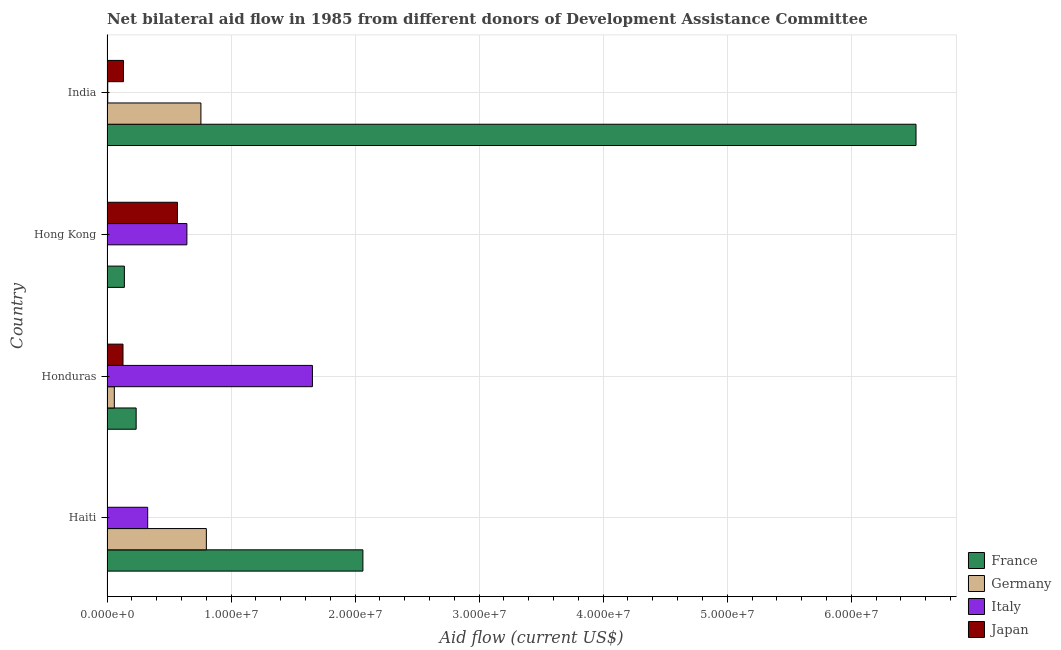How many groups of bars are there?
Keep it short and to the point. 4. Are the number of bars per tick equal to the number of legend labels?
Make the answer very short. No. What is the label of the 1st group of bars from the top?
Ensure brevity in your answer.  India. In how many cases, is the number of bars for a given country not equal to the number of legend labels?
Your response must be concise. 1. What is the amount of aid given by japan in Haiti?
Your answer should be compact. 3.00e+04. Across all countries, what is the maximum amount of aid given by germany?
Provide a succinct answer. 8.01e+06. Across all countries, what is the minimum amount of aid given by germany?
Your answer should be compact. 0. In which country was the amount of aid given by italy maximum?
Your answer should be compact. Honduras. What is the total amount of aid given by germany in the graph?
Your response must be concise. 1.62e+07. What is the difference between the amount of aid given by italy in Haiti and that in India?
Offer a terse response. 3.22e+06. What is the difference between the amount of aid given by japan in Hong Kong and the amount of aid given by italy in Haiti?
Provide a short and direct response. 2.40e+06. What is the average amount of aid given by france per country?
Your response must be concise. 2.24e+07. What is the difference between the amount of aid given by japan and amount of aid given by germany in Haiti?
Offer a very short reply. -7.98e+06. What is the ratio of the amount of aid given by france in Haiti to that in Honduras?
Offer a very short reply. 8.78. Is the difference between the amount of aid given by japan in Haiti and India greater than the difference between the amount of aid given by france in Haiti and India?
Give a very brief answer. Yes. What is the difference between the highest and the second highest amount of aid given by italy?
Your response must be concise. 1.01e+07. What is the difference between the highest and the lowest amount of aid given by italy?
Offer a terse response. 1.65e+07. In how many countries, is the amount of aid given by france greater than the average amount of aid given by france taken over all countries?
Give a very brief answer. 1. Does the graph contain grids?
Provide a short and direct response. Yes. Where does the legend appear in the graph?
Make the answer very short. Bottom right. How are the legend labels stacked?
Give a very brief answer. Vertical. What is the title of the graph?
Your response must be concise. Net bilateral aid flow in 1985 from different donors of Development Assistance Committee. What is the label or title of the X-axis?
Your response must be concise. Aid flow (current US$). What is the label or title of the Y-axis?
Offer a terse response. Country. What is the Aid flow (current US$) in France in Haiti?
Your response must be concise. 2.06e+07. What is the Aid flow (current US$) of Germany in Haiti?
Offer a terse response. 8.01e+06. What is the Aid flow (current US$) in Italy in Haiti?
Give a very brief answer. 3.28e+06. What is the Aid flow (current US$) of Japan in Haiti?
Provide a short and direct response. 3.00e+04. What is the Aid flow (current US$) of France in Honduras?
Provide a succinct answer. 2.35e+06. What is the Aid flow (current US$) of Germany in Honduras?
Your response must be concise. 5.90e+05. What is the Aid flow (current US$) of Italy in Honduras?
Ensure brevity in your answer.  1.66e+07. What is the Aid flow (current US$) in Japan in Honduras?
Your response must be concise. 1.29e+06. What is the Aid flow (current US$) in France in Hong Kong?
Provide a short and direct response. 1.40e+06. What is the Aid flow (current US$) of Italy in Hong Kong?
Make the answer very short. 6.44e+06. What is the Aid flow (current US$) in Japan in Hong Kong?
Make the answer very short. 5.68e+06. What is the Aid flow (current US$) in France in India?
Provide a short and direct response. 6.52e+07. What is the Aid flow (current US$) of Germany in India?
Ensure brevity in your answer.  7.57e+06. What is the Aid flow (current US$) in Italy in India?
Your answer should be very brief. 6.00e+04. What is the Aid flow (current US$) in Japan in India?
Your answer should be compact. 1.33e+06. Across all countries, what is the maximum Aid flow (current US$) in France?
Your answer should be compact. 6.52e+07. Across all countries, what is the maximum Aid flow (current US$) of Germany?
Ensure brevity in your answer.  8.01e+06. Across all countries, what is the maximum Aid flow (current US$) in Italy?
Your answer should be compact. 1.66e+07. Across all countries, what is the maximum Aid flow (current US$) in Japan?
Offer a very short reply. 5.68e+06. Across all countries, what is the minimum Aid flow (current US$) in France?
Make the answer very short. 1.40e+06. Across all countries, what is the minimum Aid flow (current US$) of Germany?
Offer a very short reply. 0. Across all countries, what is the minimum Aid flow (current US$) in Italy?
Your answer should be compact. 6.00e+04. Across all countries, what is the minimum Aid flow (current US$) of Japan?
Your answer should be compact. 3.00e+04. What is the total Aid flow (current US$) in France in the graph?
Make the answer very short. 8.96e+07. What is the total Aid flow (current US$) in Germany in the graph?
Ensure brevity in your answer.  1.62e+07. What is the total Aid flow (current US$) in Italy in the graph?
Keep it short and to the point. 2.63e+07. What is the total Aid flow (current US$) in Japan in the graph?
Make the answer very short. 8.33e+06. What is the difference between the Aid flow (current US$) of France in Haiti and that in Honduras?
Your answer should be compact. 1.83e+07. What is the difference between the Aid flow (current US$) of Germany in Haiti and that in Honduras?
Ensure brevity in your answer.  7.42e+06. What is the difference between the Aid flow (current US$) in Italy in Haiti and that in Honduras?
Offer a terse response. -1.33e+07. What is the difference between the Aid flow (current US$) in Japan in Haiti and that in Honduras?
Your response must be concise. -1.26e+06. What is the difference between the Aid flow (current US$) of France in Haiti and that in Hong Kong?
Keep it short and to the point. 1.92e+07. What is the difference between the Aid flow (current US$) in Italy in Haiti and that in Hong Kong?
Offer a terse response. -3.16e+06. What is the difference between the Aid flow (current US$) in Japan in Haiti and that in Hong Kong?
Give a very brief answer. -5.65e+06. What is the difference between the Aid flow (current US$) of France in Haiti and that in India?
Ensure brevity in your answer.  -4.46e+07. What is the difference between the Aid flow (current US$) of Germany in Haiti and that in India?
Provide a short and direct response. 4.40e+05. What is the difference between the Aid flow (current US$) of Italy in Haiti and that in India?
Keep it short and to the point. 3.22e+06. What is the difference between the Aid flow (current US$) of Japan in Haiti and that in India?
Provide a short and direct response. -1.30e+06. What is the difference between the Aid flow (current US$) of France in Honduras and that in Hong Kong?
Ensure brevity in your answer.  9.50e+05. What is the difference between the Aid flow (current US$) in Italy in Honduras and that in Hong Kong?
Keep it short and to the point. 1.01e+07. What is the difference between the Aid flow (current US$) in Japan in Honduras and that in Hong Kong?
Ensure brevity in your answer.  -4.39e+06. What is the difference between the Aid flow (current US$) in France in Honduras and that in India?
Your response must be concise. -6.29e+07. What is the difference between the Aid flow (current US$) of Germany in Honduras and that in India?
Keep it short and to the point. -6.98e+06. What is the difference between the Aid flow (current US$) in Italy in Honduras and that in India?
Keep it short and to the point. 1.65e+07. What is the difference between the Aid flow (current US$) in France in Hong Kong and that in India?
Your answer should be very brief. -6.38e+07. What is the difference between the Aid flow (current US$) of Italy in Hong Kong and that in India?
Offer a terse response. 6.38e+06. What is the difference between the Aid flow (current US$) of Japan in Hong Kong and that in India?
Ensure brevity in your answer.  4.35e+06. What is the difference between the Aid flow (current US$) in France in Haiti and the Aid flow (current US$) in Germany in Honduras?
Give a very brief answer. 2.00e+07. What is the difference between the Aid flow (current US$) of France in Haiti and the Aid flow (current US$) of Italy in Honduras?
Offer a terse response. 4.07e+06. What is the difference between the Aid flow (current US$) in France in Haiti and the Aid flow (current US$) in Japan in Honduras?
Your answer should be compact. 1.93e+07. What is the difference between the Aid flow (current US$) in Germany in Haiti and the Aid flow (current US$) in Italy in Honduras?
Give a very brief answer. -8.55e+06. What is the difference between the Aid flow (current US$) in Germany in Haiti and the Aid flow (current US$) in Japan in Honduras?
Offer a very short reply. 6.72e+06. What is the difference between the Aid flow (current US$) of Italy in Haiti and the Aid flow (current US$) of Japan in Honduras?
Your answer should be compact. 1.99e+06. What is the difference between the Aid flow (current US$) in France in Haiti and the Aid flow (current US$) in Italy in Hong Kong?
Make the answer very short. 1.42e+07. What is the difference between the Aid flow (current US$) of France in Haiti and the Aid flow (current US$) of Japan in Hong Kong?
Make the answer very short. 1.50e+07. What is the difference between the Aid flow (current US$) in Germany in Haiti and the Aid flow (current US$) in Italy in Hong Kong?
Offer a terse response. 1.57e+06. What is the difference between the Aid flow (current US$) of Germany in Haiti and the Aid flow (current US$) of Japan in Hong Kong?
Ensure brevity in your answer.  2.33e+06. What is the difference between the Aid flow (current US$) in Italy in Haiti and the Aid flow (current US$) in Japan in Hong Kong?
Provide a short and direct response. -2.40e+06. What is the difference between the Aid flow (current US$) of France in Haiti and the Aid flow (current US$) of Germany in India?
Ensure brevity in your answer.  1.31e+07. What is the difference between the Aid flow (current US$) of France in Haiti and the Aid flow (current US$) of Italy in India?
Offer a very short reply. 2.06e+07. What is the difference between the Aid flow (current US$) in France in Haiti and the Aid flow (current US$) in Japan in India?
Your answer should be very brief. 1.93e+07. What is the difference between the Aid flow (current US$) in Germany in Haiti and the Aid flow (current US$) in Italy in India?
Keep it short and to the point. 7.95e+06. What is the difference between the Aid flow (current US$) in Germany in Haiti and the Aid flow (current US$) in Japan in India?
Your answer should be very brief. 6.68e+06. What is the difference between the Aid flow (current US$) in Italy in Haiti and the Aid flow (current US$) in Japan in India?
Keep it short and to the point. 1.95e+06. What is the difference between the Aid flow (current US$) in France in Honduras and the Aid flow (current US$) in Italy in Hong Kong?
Ensure brevity in your answer.  -4.09e+06. What is the difference between the Aid flow (current US$) in France in Honduras and the Aid flow (current US$) in Japan in Hong Kong?
Provide a succinct answer. -3.33e+06. What is the difference between the Aid flow (current US$) of Germany in Honduras and the Aid flow (current US$) of Italy in Hong Kong?
Your answer should be very brief. -5.85e+06. What is the difference between the Aid flow (current US$) in Germany in Honduras and the Aid flow (current US$) in Japan in Hong Kong?
Ensure brevity in your answer.  -5.09e+06. What is the difference between the Aid flow (current US$) in Italy in Honduras and the Aid flow (current US$) in Japan in Hong Kong?
Your response must be concise. 1.09e+07. What is the difference between the Aid flow (current US$) in France in Honduras and the Aid flow (current US$) in Germany in India?
Provide a short and direct response. -5.22e+06. What is the difference between the Aid flow (current US$) in France in Honduras and the Aid flow (current US$) in Italy in India?
Keep it short and to the point. 2.29e+06. What is the difference between the Aid flow (current US$) in France in Honduras and the Aid flow (current US$) in Japan in India?
Provide a short and direct response. 1.02e+06. What is the difference between the Aid flow (current US$) of Germany in Honduras and the Aid flow (current US$) of Italy in India?
Provide a succinct answer. 5.30e+05. What is the difference between the Aid flow (current US$) in Germany in Honduras and the Aid flow (current US$) in Japan in India?
Your response must be concise. -7.40e+05. What is the difference between the Aid flow (current US$) of Italy in Honduras and the Aid flow (current US$) of Japan in India?
Your answer should be very brief. 1.52e+07. What is the difference between the Aid flow (current US$) in France in Hong Kong and the Aid flow (current US$) in Germany in India?
Your answer should be compact. -6.17e+06. What is the difference between the Aid flow (current US$) of France in Hong Kong and the Aid flow (current US$) of Italy in India?
Offer a very short reply. 1.34e+06. What is the difference between the Aid flow (current US$) of Italy in Hong Kong and the Aid flow (current US$) of Japan in India?
Ensure brevity in your answer.  5.11e+06. What is the average Aid flow (current US$) in France per country?
Offer a very short reply. 2.24e+07. What is the average Aid flow (current US$) in Germany per country?
Offer a terse response. 4.04e+06. What is the average Aid flow (current US$) in Italy per country?
Keep it short and to the point. 6.58e+06. What is the average Aid flow (current US$) in Japan per country?
Offer a terse response. 2.08e+06. What is the difference between the Aid flow (current US$) in France and Aid flow (current US$) in Germany in Haiti?
Keep it short and to the point. 1.26e+07. What is the difference between the Aid flow (current US$) of France and Aid flow (current US$) of Italy in Haiti?
Provide a short and direct response. 1.74e+07. What is the difference between the Aid flow (current US$) in France and Aid flow (current US$) in Japan in Haiti?
Your answer should be compact. 2.06e+07. What is the difference between the Aid flow (current US$) of Germany and Aid flow (current US$) of Italy in Haiti?
Ensure brevity in your answer.  4.73e+06. What is the difference between the Aid flow (current US$) in Germany and Aid flow (current US$) in Japan in Haiti?
Ensure brevity in your answer.  7.98e+06. What is the difference between the Aid flow (current US$) in Italy and Aid flow (current US$) in Japan in Haiti?
Your answer should be very brief. 3.25e+06. What is the difference between the Aid flow (current US$) in France and Aid flow (current US$) in Germany in Honduras?
Your response must be concise. 1.76e+06. What is the difference between the Aid flow (current US$) of France and Aid flow (current US$) of Italy in Honduras?
Offer a terse response. -1.42e+07. What is the difference between the Aid flow (current US$) of France and Aid flow (current US$) of Japan in Honduras?
Make the answer very short. 1.06e+06. What is the difference between the Aid flow (current US$) of Germany and Aid flow (current US$) of Italy in Honduras?
Your answer should be compact. -1.60e+07. What is the difference between the Aid flow (current US$) of Germany and Aid flow (current US$) of Japan in Honduras?
Provide a succinct answer. -7.00e+05. What is the difference between the Aid flow (current US$) of Italy and Aid flow (current US$) of Japan in Honduras?
Provide a short and direct response. 1.53e+07. What is the difference between the Aid flow (current US$) of France and Aid flow (current US$) of Italy in Hong Kong?
Keep it short and to the point. -5.04e+06. What is the difference between the Aid flow (current US$) of France and Aid flow (current US$) of Japan in Hong Kong?
Ensure brevity in your answer.  -4.28e+06. What is the difference between the Aid flow (current US$) of Italy and Aid flow (current US$) of Japan in Hong Kong?
Give a very brief answer. 7.60e+05. What is the difference between the Aid flow (current US$) in France and Aid flow (current US$) in Germany in India?
Provide a short and direct response. 5.76e+07. What is the difference between the Aid flow (current US$) of France and Aid flow (current US$) of Italy in India?
Offer a very short reply. 6.52e+07. What is the difference between the Aid flow (current US$) of France and Aid flow (current US$) of Japan in India?
Offer a very short reply. 6.39e+07. What is the difference between the Aid flow (current US$) of Germany and Aid flow (current US$) of Italy in India?
Your response must be concise. 7.51e+06. What is the difference between the Aid flow (current US$) in Germany and Aid flow (current US$) in Japan in India?
Your response must be concise. 6.24e+06. What is the difference between the Aid flow (current US$) of Italy and Aid flow (current US$) of Japan in India?
Your answer should be compact. -1.27e+06. What is the ratio of the Aid flow (current US$) in France in Haiti to that in Honduras?
Provide a short and direct response. 8.78. What is the ratio of the Aid flow (current US$) of Germany in Haiti to that in Honduras?
Your answer should be very brief. 13.58. What is the ratio of the Aid flow (current US$) in Italy in Haiti to that in Honduras?
Your response must be concise. 0.2. What is the ratio of the Aid flow (current US$) of Japan in Haiti to that in Honduras?
Your answer should be very brief. 0.02. What is the ratio of the Aid flow (current US$) of France in Haiti to that in Hong Kong?
Keep it short and to the point. 14.74. What is the ratio of the Aid flow (current US$) of Italy in Haiti to that in Hong Kong?
Offer a terse response. 0.51. What is the ratio of the Aid flow (current US$) of Japan in Haiti to that in Hong Kong?
Offer a terse response. 0.01. What is the ratio of the Aid flow (current US$) in France in Haiti to that in India?
Your response must be concise. 0.32. What is the ratio of the Aid flow (current US$) in Germany in Haiti to that in India?
Keep it short and to the point. 1.06. What is the ratio of the Aid flow (current US$) of Italy in Haiti to that in India?
Offer a terse response. 54.67. What is the ratio of the Aid flow (current US$) of Japan in Haiti to that in India?
Your answer should be compact. 0.02. What is the ratio of the Aid flow (current US$) of France in Honduras to that in Hong Kong?
Give a very brief answer. 1.68. What is the ratio of the Aid flow (current US$) in Italy in Honduras to that in Hong Kong?
Offer a very short reply. 2.57. What is the ratio of the Aid flow (current US$) of Japan in Honduras to that in Hong Kong?
Your answer should be very brief. 0.23. What is the ratio of the Aid flow (current US$) in France in Honduras to that in India?
Keep it short and to the point. 0.04. What is the ratio of the Aid flow (current US$) of Germany in Honduras to that in India?
Give a very brief answer. 0.08. What is the ratio of the Aid flow (current US$) in Italy in Honduras to that in India?
Give a very brief answer. 276. What is the ratio of the Aid flow (current US$) in Japan in Honduras to that in India?
Keep it short and to the point. 0.97. What is the ratio of the Aid flow (current US$) in France in Hong Kong to that in India?
Provide a succinct answer. 0.02. What is the ratio of the Aid flow (current US$) of Italy in Hong Kong to that in India?
Offer a very short reply. 107.33. What is the ratio of the Aid flow (current US$) in Japan in Hong Kong to that in India?
Ensure brevity in your answer.  4.27. What is the difference between the highest and the second highest Aid flow (current US$) in France?
Provide a succinct answer. 4.46e+07. What is the difference between the highest and the second highest Aid flow (current US$) in Germany?
Your answer should be compact. 4.40e+05. What is the difference between the highest and the second highest Aid flow (current US$) of Italy?
Offer a terse response. 1.01e+07. What is the difference between the highest and the second highest Aid flow (current US$) of Japan?
Make the answer very short. 4.35e+06. What is the difference between the highest and the lowest Aid flow (current US$) in France?
Ensure brevity in your answer.  6.38e+07. What is the difference between the highest and the lowest Aid flow (current US$) of Germany?
Offer a very short reply. 8.01e+06. What is the difference between the highest and the lowest Aid flow (current US$) in Italy?
Give a very brief answer. 1.65e+07. What is the difference between the highest and the lowest Aid flow (current US$) of Japan?
Keep it short and to the point. 5.65e+06. 